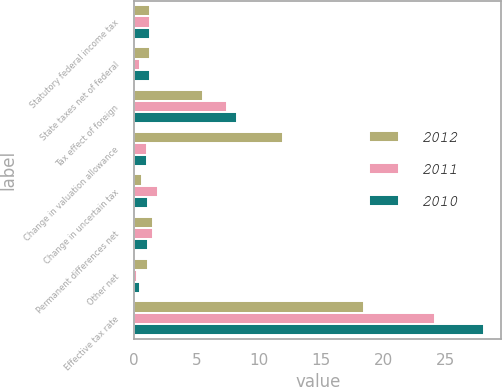<chart> <loc_0><loc_0><loc_500><loc_500><stacked_bar_chart><ecel><fcel>Statutory federal income tax<fcel>State taxes net of federal<fcel>Tax effect of foreign<fcel>Change in valuation allowance<fcel>Change in uncertain tax<fcel>Permanent differences net<fcel>Other net<fcel>Effective tax rate<nl><fcel>2012<fcel>1.3<fcel>1.3<fcel>5.5<fcel>12<fcel>0.6<fcel>1.5<fcel>1.1<fcel>18.5<nl><fcel>2011<fcel>1.3<fcel>0.5<fcel>7.5<fcel>1<fcel>1.9<fcel>1.5<fcel>0.2<fcel>24.2<nl><fcel>2010<fcel>1.3<fcel>1.3<fcel>8.3<fcel>1<fcel>1.1<fcel>1.1<fcel>0.5<fcel>28.1<nl></chart> 